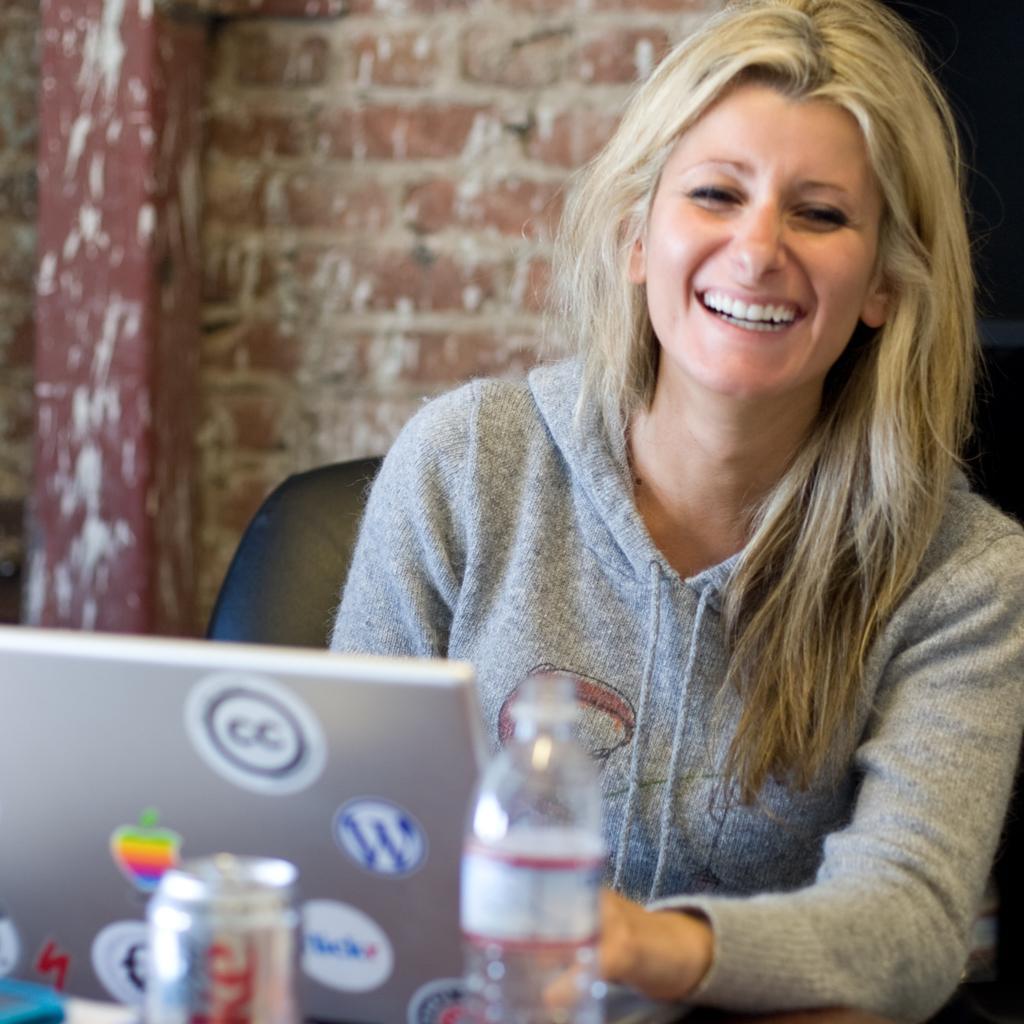Can you describe this image briefly? In this picture a lady is sitting on the chair and smiling. She has a laptop, a coke can, water bottle in front of her and in the backdrop there is a wall 